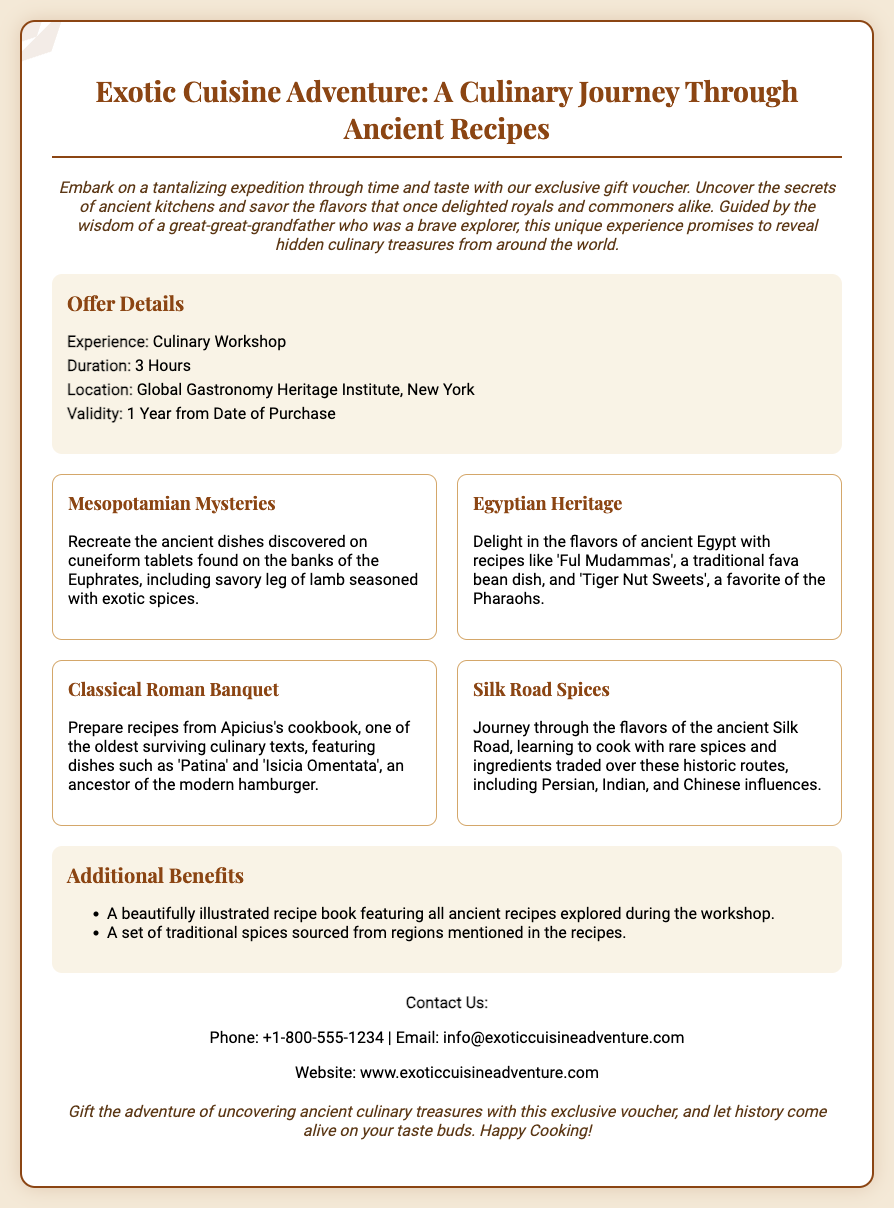What is the experience offered? The document states that the experience offered is a Culinary Workshop.
Answer: Culinary Workshop What is the duration of the workshop? The duration of the workshop is specified in the offer details section of the document, which is 3 hours.
Answer: 3 Hours Where is the workshop located? The location of the workshop is provided in the offer details section, specifically at the Global Gastronomy Heritage Institute, New York.
Answer: Global Gastronomy Heritage Institute, New York How long is the voucher valid for? The validity period of the voucher is mentioned as 1 Year from Date of Purchase.
Answer: 1 Year from Date of Purchase What ancient dish involves leg of lamb? The dish mentioned involving leg of lamb is rooted in Mesopotamian recipes that are recreated during the workshop.
Answer: Mesopotamian Mysteries Which dish is a traditional fava bean dish? The dish referred to as a traditional fava bean dish is 'Ful Mudammas' from the Egyptian Heritage section.
Answer: Ful Mudammas What is included in the additional benefits? The additional benefits section outlines two items included: a beautifully illustrated recipe book and a set of traditional spices.
Answer: Illustrated recipe book, traditional spices How does this voucher gift recipients? The document promotes gifting the adventure of uncovering ancient culinary treasures, tailored to the exploration theme of the experience.
Answer: Uncovering ancient culinary treasures 